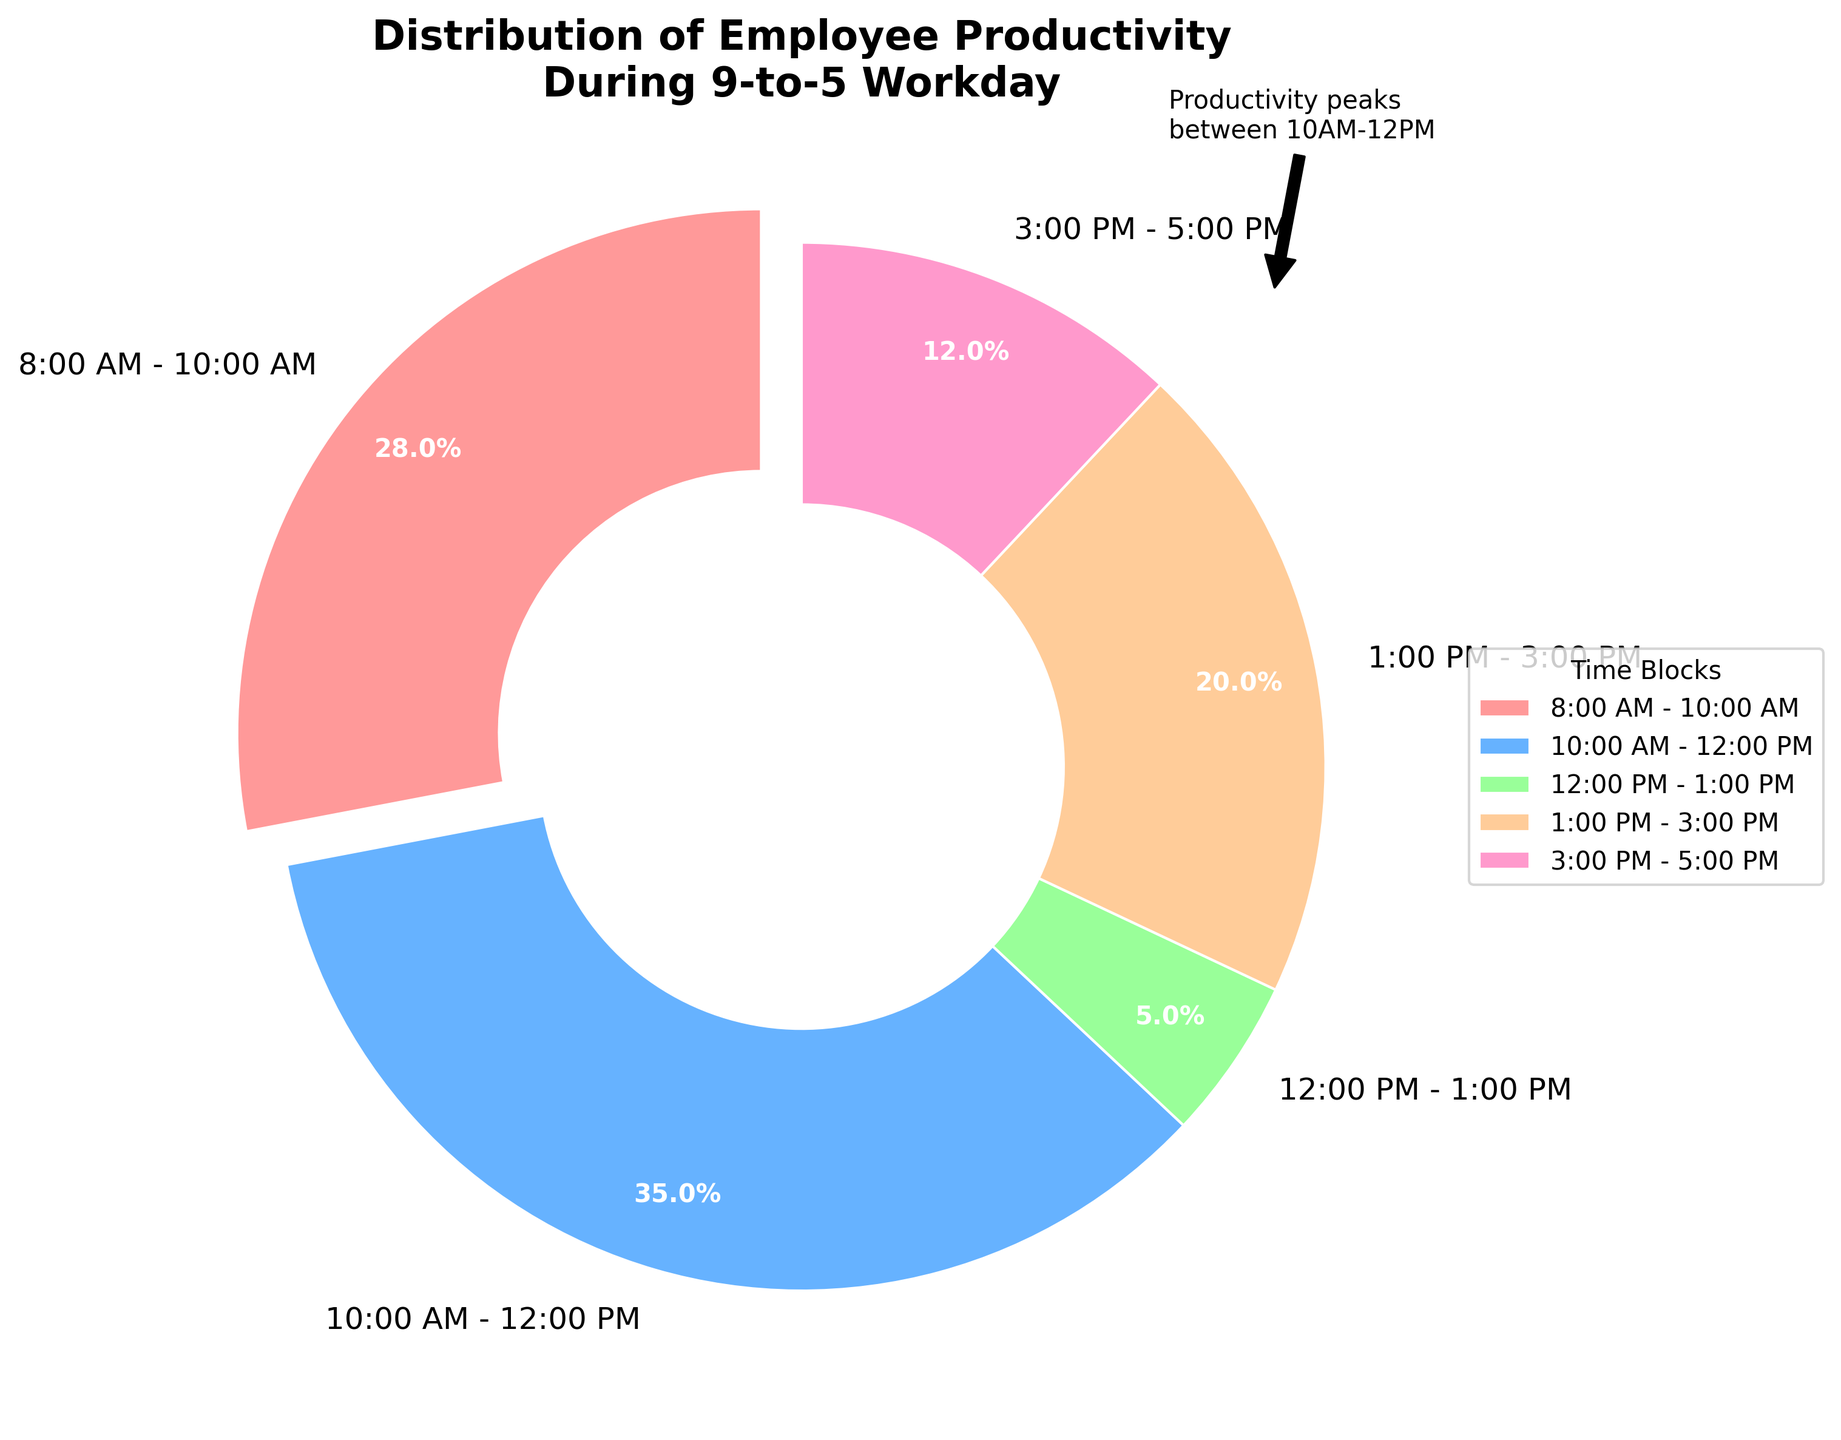What time block shows the highest employee productivity? The time block from 10:00 AM - 12:00 PM has the largest portion of the pie chart, indicating it has the highest productivity.
Answer: 10:00 AM - 12:00 PM What percentage of productivity occurs before lunch (12:00 PM)? To find the productivity before lunch, sum the percentages of the 8:00 AM - 10:00 AM and 10:00 AM - 12:00 PM time blocks: 28% + 35% = 63%.
Answer: 63% How does productivity from 1:00 PM - 3:00 PM compare to productivity from 3:00 PM - 5:00 PM? The productivity from 1:00 PM - 3:00 PM is 20%, which is greater than the 12% productivity from 3:00 PM - 5:00 PM.
Answer: 1:00 PM - 3:00 PM is higher Which time block has the lowest productivity percentage, and what is its value? The smallest slice of the pie chart corresponds to 12:00 PM - 1:00 PM with a productivity percentage of 5%.
Answer: 12:00 PM - 1:00 PM, 5% What is the total productivity combined for the first and last time blocks of the day? To calculate the combined productivity of the first (8:00 AM - 10:00 AM) and last (3:00 PM - 5:00 PM) time blocks, sum their percentages: 28% + 12% = 40%.
Answer: 40% What is the average productivity of time blocks after lunch (1:00 PM - 5:00 PM)? The productivity percentages after lunch are 20% (1:00 PM - 3:00 PM) and 12% (3:00 PM - 5:00 PM). Average them: (20% + 12%) / 2 = 16%.
Answer: 16% How much more productive is the 10:00 AM - 12:00 PM block compared to 3:00 PM - 5:00 PM? The productivity difference can be found by subtracting the 3:00 PM - 5:00 PM percentage from the 10:00 AM - 12:00 PM percentage: 35% - 12% = 23%.
Answer: 23% During which period does productivity drop sharpest, and what are the percentages involved? The sharpest drop in productivity is from 10:00 AM - 12:00 PM (35%) to 12:00 PM - 1:00 PM (5%), which results in a drop of 30%.
Answer: 10:00 AM - 1:00 PM, 30% What is the combined productivity percentage for the time blocks from 12:00 PM to 5:00 PM? To find the combined productivity from 12:00 PM - 5:00 PM, sum the percentages of 12:00 PM - 1:00 PM (5%), 1:00 PM - 3:00 PM (20%), and 3:00 PM - 5:00 PM (12%): 5% + 20% + 12% = 37%.
Answer: 37% 